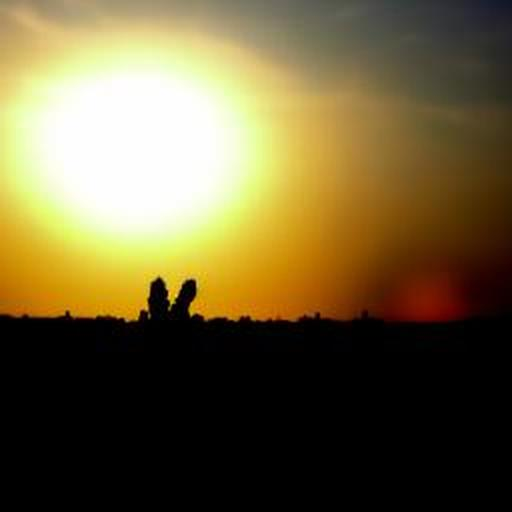Is this image suitable for use in a travel brochure? Certainly, this image could be suitable for a travel brochure, especially if it's promoting a destination known for its stunning sunsets and peaceful evenings. However, enhancing the image quality to ensure it prints well would be recommended. 